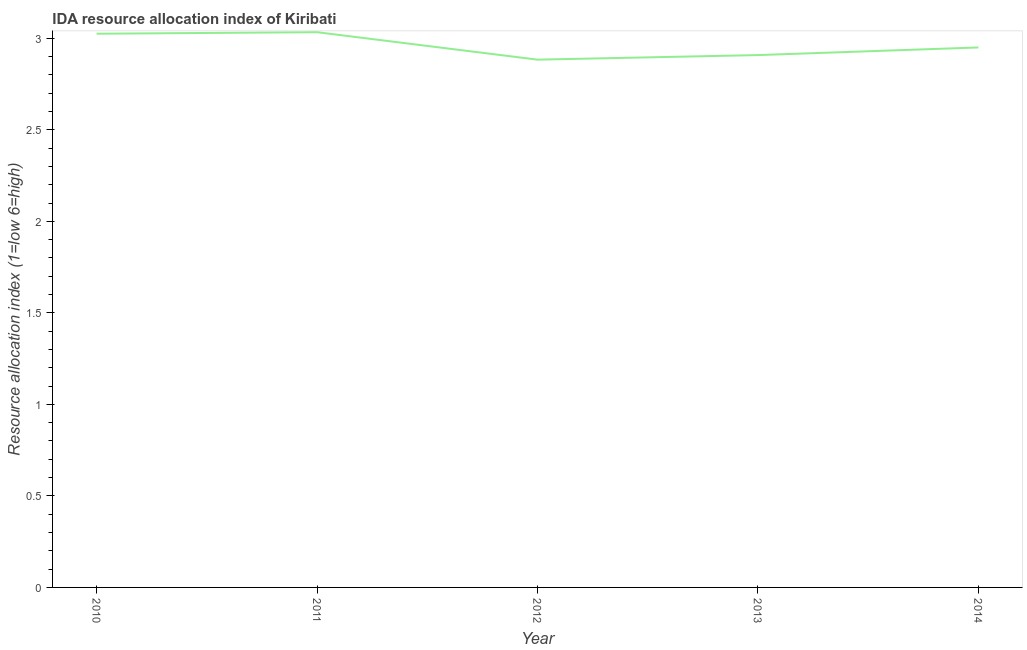What is the ida resource allocation index in 2014?
Offer a terse response. 2.95. Across all years, what is the maximum ida resource allocation index?
Provide a short and direct response. 3.03. Across all years, what is the minimum ida resource allocation index?
Make the answer very short. 2.88. In which year was the ida resource allocation index maximum?
Provide a short and direct response. 2011. In which year was the ida resource allocation index minimum?
Offer a terse response. 2012. What is the sum of the ida resource allocation index?
Offer a very short reply. 14.8. What is the difference between the ida resource allocation index in 2012 and 2014?
Keep it short and to the point. -0.07. What is the average ida resource allocation index per year?
Your answer should be very brief. 2.96. What is the median ida resource allocation index?
Your answer should be compact. 2.95. In how many years, is the ida resource allocation index greater than 1.2 ?
Give a very brief answer. 5. What is the ratio of the ida resource allocation index in 2010 to that in 2014?
Your answer should be compact. 1.03. Is the ida resource allocation index in 2010 less than that in 2013?
Offer a terse response. No. Is the difference between the ida resource allocation index in 2012 and 2013 greater than the difference between any two years?
Keep it short and to the point. No. What is the difference between the highest and the second highest ida resource allocation index?
Your response must be concise. 0.01. What is the difference between the highest and the lowest ida resource allocation index?
Your answer should be very brief. 0.15. In how many years, is the ida resource allocation index greater than the average ida resource allocation index taken over all years?
Ensure brevity in your answer.  2. Does the ida resource allocation index monotonically increase over the years?
Ensure brevity in your answer.  No. How many years are there in the graph?
Your answer should be compact. 5. What is the difference between two consecutive major ticks on the Y-axis?
Provide a short and direct response. 0.5. Does the graph contain grids?
Offer a very short reply. No. What is the title of the graph?
Offer a terse response. IDA resource allocation index of Kiribati. What is the label or title of the Y-axis?
Your answer should be compact. Resource allocation index (1=low 6=high). What is the Resource allocation index (1=low 6=high) in 2010?
Your response must be concise. 3.02. What is the Resource allocation index (1=low 6=high) of 2011?
Provide a short and direct response. 3.03. What is the Resource allocation index (1=low 6=high) of 2012?
Ensure brevity in your answer.  2.88. What is the Resource allocation index (1=low 6=high) of 2013?
Provide a short and direct response. 2.91. What is the Resource allocation index (1=low 6=high) in 2014?
Give a very brief answer. 2.95. What is the difference between the Resource allocation index (1=low 6=high) in 2010 and 2011?
Offer a very short reply. -0.01. What is the difference between the Resource allocation index (1=low 6=high) in 2010 and 2012?
Make the answer very short. 0.14. What is the difference between the Resource allocation index (1=low 6=high) in 2010 and 2013?
Provide a short and direct response. 0.12. What is the difference between the Resource allocation index (1=low 6=high) in 2010 and 2014?
Your answer should be compact. 0.07. What is the difference between the Resource allocation index (1=low 6=high) in 2011 and 2013?
Ensure brevity in your answer.  0.12. What is the difference between the Resource allocation index (1=low 6=high) in 2011 and 2014?
Keep it short and to the point. 0.08. What is the difference between the Resource allocation index (1=low 6=high) in 2012 and 2013?
Your response must be concise. -0.03. What is the difference between the Resource allocation index (1=low 6=high) in 2012 and 2014?
Keep it short and to the point. -0.07. What is the difference between the Resource allocation index (1=low 6=high) in 2013 and 2014?
Your answer should be compact. -0.04. What is the ratio of the Resource allocation index (1=low 6=high) in 2010 to that in 2012?
Provide a succinct answer. 1.05. What is the ratio of the Resource allocation index (1=low 6=high) in 2011 to that in 2012?
Your answer should be very brief. 1.05. What is the ratio of the Resource allocation index (1=low 6=high) in 2011 to that in 2013?
Your answer should be very brief. 1.04. What is the ratio of the Resource allocation index (1=low 6=high) in 2011 to that in 2014?
Provide a succinct answer. 1.03. What is the ratio of the Resource allocation index (1=low 6=high) in 2013 to that in 2014?
Keep it short and to the point. 0.99. 